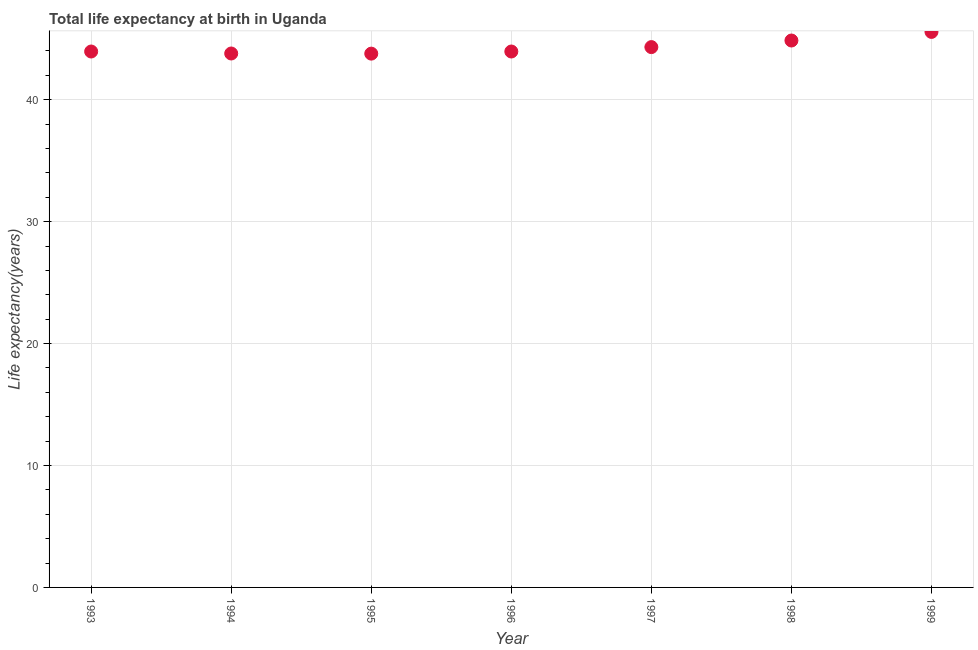What is the life expectancy at birth in 1998?
Your response must be concise. 44.86. Across all years, what is the maximum life expectancy at birth?
Make the answer very short. 45.56. Across all years, what is the minimum life expectancy at birth?
Provide a short and direct response. 43.78. In which year was the life expectancy at birth minimum?
Make the answer very short. 1995. What is the sum of the life expectancy at birth?
Provide a short and direct response. 310.24. What is the difference between the life expectancy at birth in 1994 and 1996?
Provide a succinct answer. -0.16. What is the average life expectancy at birth per year?
Offer a terse response. 44.32. What is the median life expectancy at birth?
Keep it short and to the point. 43.96. Do a majority of the years between 1999 and 1995 (inclusive) have life expectancy at birth greater than 24 years?
Provide a succinct answer. Yes. What is the ratio of the life expectancy at birth in 1996 to that in 1998?
Offer a very short reply. 0.98. What is the difference between the highest and the second highest life expectancy at birth?
Provide a short and direct response. 0.71. Is the sum of the life expectancy at birth in 1994 and 1995 greater than the maximum life expectancy at birth across all years?
Offer a terse response. Yes. What is the difference between the highest and the lowest life expectancy at birth?
Provide a short and direct response. 1.78. In how many years, is the life expectancy at birth greater than the average life expectancy at birth taken over all years?
Give a very brief answer. 2. What is the difference between two consecutive major ticks on the Y-axis?
Keep it short and to the point. 10. Are the values on the major ticks of Y-axis written in scientific E-notation?
Offer a terse response. No. What is the title of the graph?
Offer a terse response. Total life expectancy at birth in Uganda. What is the label or title of the Y-axis?
Ensure brevity in your answer.  Life expectancy(years). What is the Life expectancy(years) in 1993?
Offer a terse response. 43.96. What is the Life expectancy(years) in 1994?
Provide a succinct answer. 43.79. What is the Life expectancy(years) in 1995?
Ensure brevity in your answer.  43.78. What is the Life expectancy(years) in 1996?
Offer a very short reply. 43.96. What is the Life expectancy(years) in 1997?
Make the answer very short. 44.32. What is the Life expectancy(years) in 1998?
Offer a very short reply. 44.86. What is the Life expectancy(years) in 1999?
Offer a very short reply. 45.56. What is the difference between the Life expectancy(years) in 1993 and 1994?
Give a very brief answer. 0.16. What is the difference between the Life expectancy(years) in 1993 and 1995?
Give a very brief answer. 0.17. What is the difference between the Life expectancy(years) in 1993 and 1996?
Your answer should be compact. -7e-5. What is the difference between the Life expectancy(years) in 1993 and 1997?
Ensure brevity in your answer.  -0.36. What is the difference between the Life expectancy(years) in 1993 and 1998?
Your answer should be very brief. -0.9. What is the difference between the Life expectancy(years) in 1993 and 1999?
Keep it short and to the point. -1.61. What is the difference between the Life expectancy(years) in 1994 and 1995?
Provide a short and direct response. 0.01. What is the difference between the Life expectancy(years) in 1994 and 1996?
Ensure brevity in your answer.  -0.16. What is the difference between the Life expectancy(years) in 1994 and 1997?
Offer a terse response. -0.52. What is the difference between the Life expectancy(years) in 1994 and 1998?
Offer a very short reply. -1.06. What is the difference between the Life expectancy(years) in 1994 and 1999?
Provide a succinct answer. -1.77. What is the difference between the Life expectancy(years) in 1995 and 1996?
Offer a terse response. -0.17. What is the difference between the Life expectancy(years) in 1995 and 1997?
Provide a short and direct response. -0.54. What is the difference between the Life expectancy(years) in 1995 and 1998?
Your response must be concise. -1.08. What is the difference between the Life expectancy(years) in 1995 and 1999?
Your response must be concise. -1.78. What is the difference between the Life expectancy(years) in 1996 and 1997?
Offer a very short reply. -0.36. What is the difference between the Life expectancy(years) in 1996 and 1998?
Give a very brief answer. -0.9. What is the difference between the Life expectancy(years) in 1996 and 1999?
Provide a succinct answer. -1.61. What is the difference between the Life expectancy(years) in 1997 and 1998?
Provide a succinct answer. -0.54. What is the difference between the Life expectancy(years) in 1997 and 1999?
Keep it short and to the point. -1.25. What is the difference between the Life expectancy(years) in 1998 and 1999?
Make the answer very short. -0.71. What is the ratio of the Life expectancy(years) in 1993 to that in 1994?
Ensure brevity in your answer.  1. What is the ratio of the Life expectancy(years) in 1993 to that in 1995?
Your answer should be very brief. 1. What is the ratio of the Life expectancy(years) in 1993 to that in 1997?
Give a very brief answer. 0.99. What is the ratio of the Life expectancy(years) in 1993 to that in 1998?
Keep it short and to the point. 0.98. What is the ratio of the Life expectancy(years) in 1993 to that in 1999?
Keep it short and to the point. 0.96. What is the ratio of the Life expectancy(years) in 1994 to that in 1995?
Make the answer very short. 1. What is the ratio of the Life expectancy(years) in 1994 to that in 1996?
Keep it short and to the point. 1. What is the ratio of the Life expectancy(years) in 1995 to that in 1996?
Ensure brevity in your answer.  1. What is the ratio of the Life expectancy(years) in 1995 to that in 1998?
Ensure brevity in your answer.  0.98. What is the ratio of the Life expectancy(years) in 1995 to that in 1999?
Offer a very short reply. 0.96. What is the ratio of the Life expectancy(years) in 1996 to that in 1998?
Your answer should be compact. 0.98. What is the ratio of the Life expectancy(years) in 1996 to that in 1999?
Provide a short and direct response. 0.96. What is the ratio of the Life expectancy(years) in 1997 to that in 1999?
Provide a short and direct response. 0.97. 